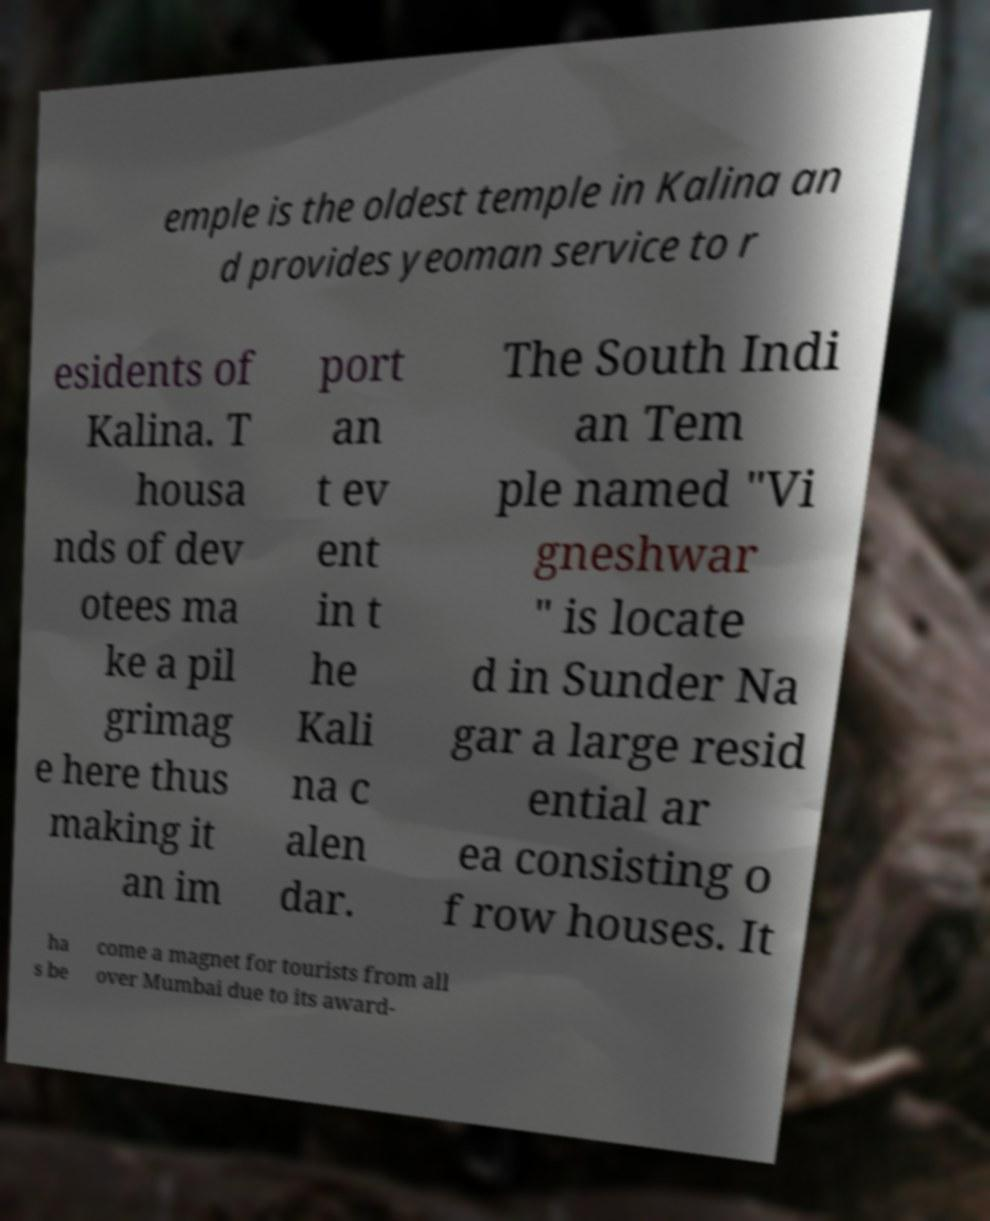Could you assist in decoding the text presented in this image and type it out clearly? emple is the oldest temple in Kalina an d provides yeoman service to r esidents of Kalina. T housa nds of dev otees ma ke a pil grimag e here thus making it an im port an t ev ent in t he Kali na c alen dar. The South Indi an Tem ple named "Vi gneshwar " is locate d in Sunder Na gar a large resid ential ar ea consisting o f row houses. It ha s be come a magnet for tourists from all over Mumbai due to its award- 